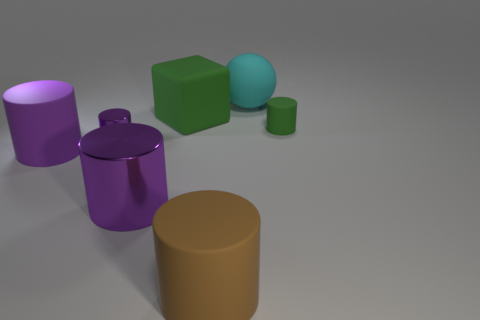Subtract all purple cylinders. How many were subtracted if there are1purple cylinders left? 2 Subtract all rubber cylinders. How many cylinders are left? 2 Subtract all brown cylinders. How many cylinders are left? 4 Subtract 3 cylinders. How many cylinders are left? 2 Add 2 cylinders. How many objects exist? 9 Subtract all cubes. How many objects are left? 6 Add 2 large brown things. How many large brown things are left? 3 Add 1 large matte cylinders. How many large matte cylinders exist? 3 Subtract 0 brown spheres. How many objects are left? 7 Subtract all purple spheres. Subtract all gray blocks. How many spheres are left? 1 